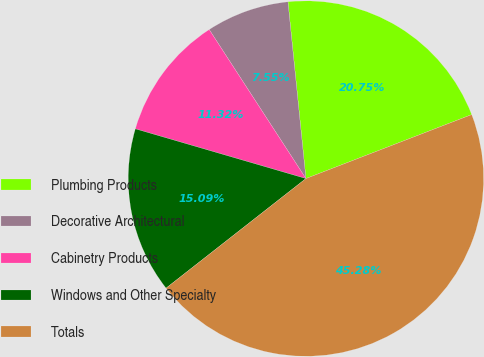Convert chart. <chart><loc_0><loc_0><loc_500><loc_500><pie_chart><fcel>Plumbing Products<fcel>Decorative Architectural<fcel>Cabinetry Products<fcel>Windows and Other Specialty<fcel>Totals<nl><fcel>20.75%<fcel>7.55%<fcel>11.32%<fcel>15.09%<fcel>45.28%<nl></chart> 